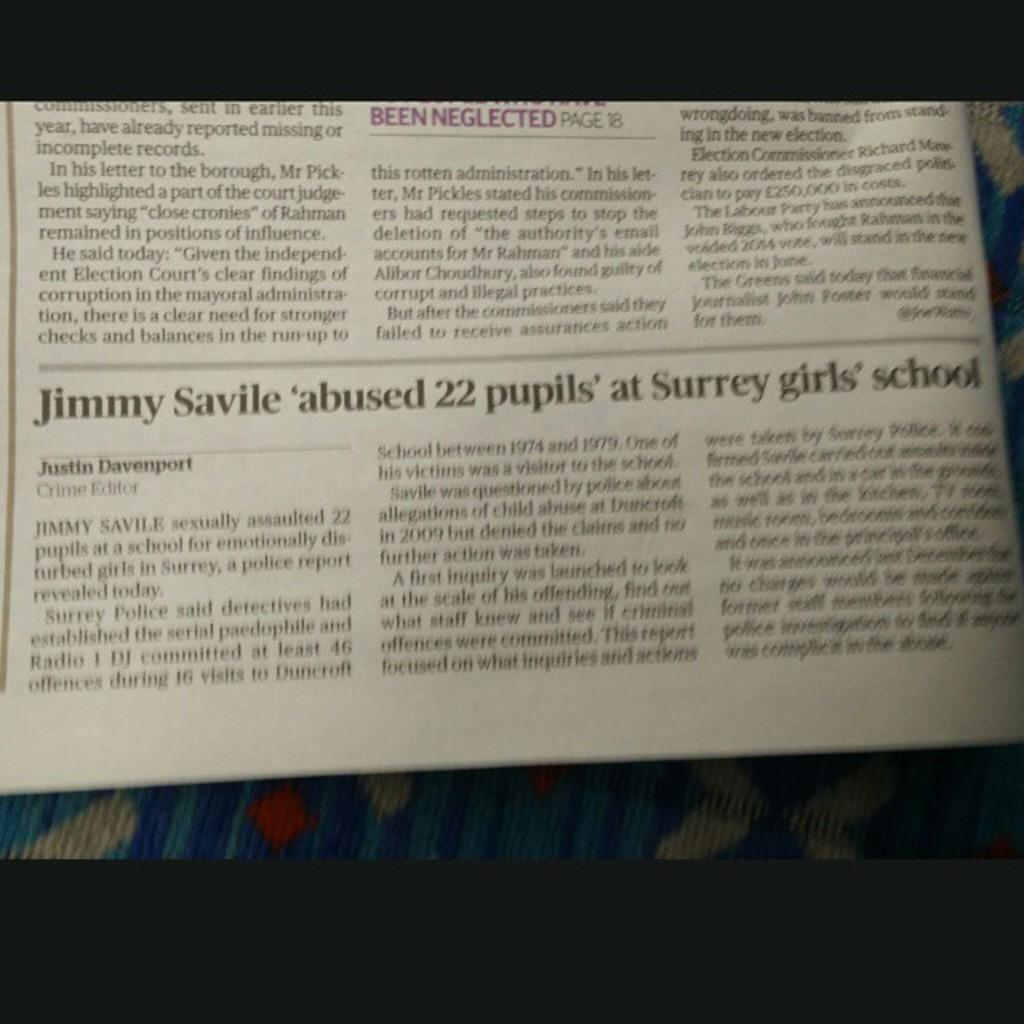<image>
Describe the image concisely. Newspaper about Jimmy Savile abused 22 pupils at Surrey girls school 